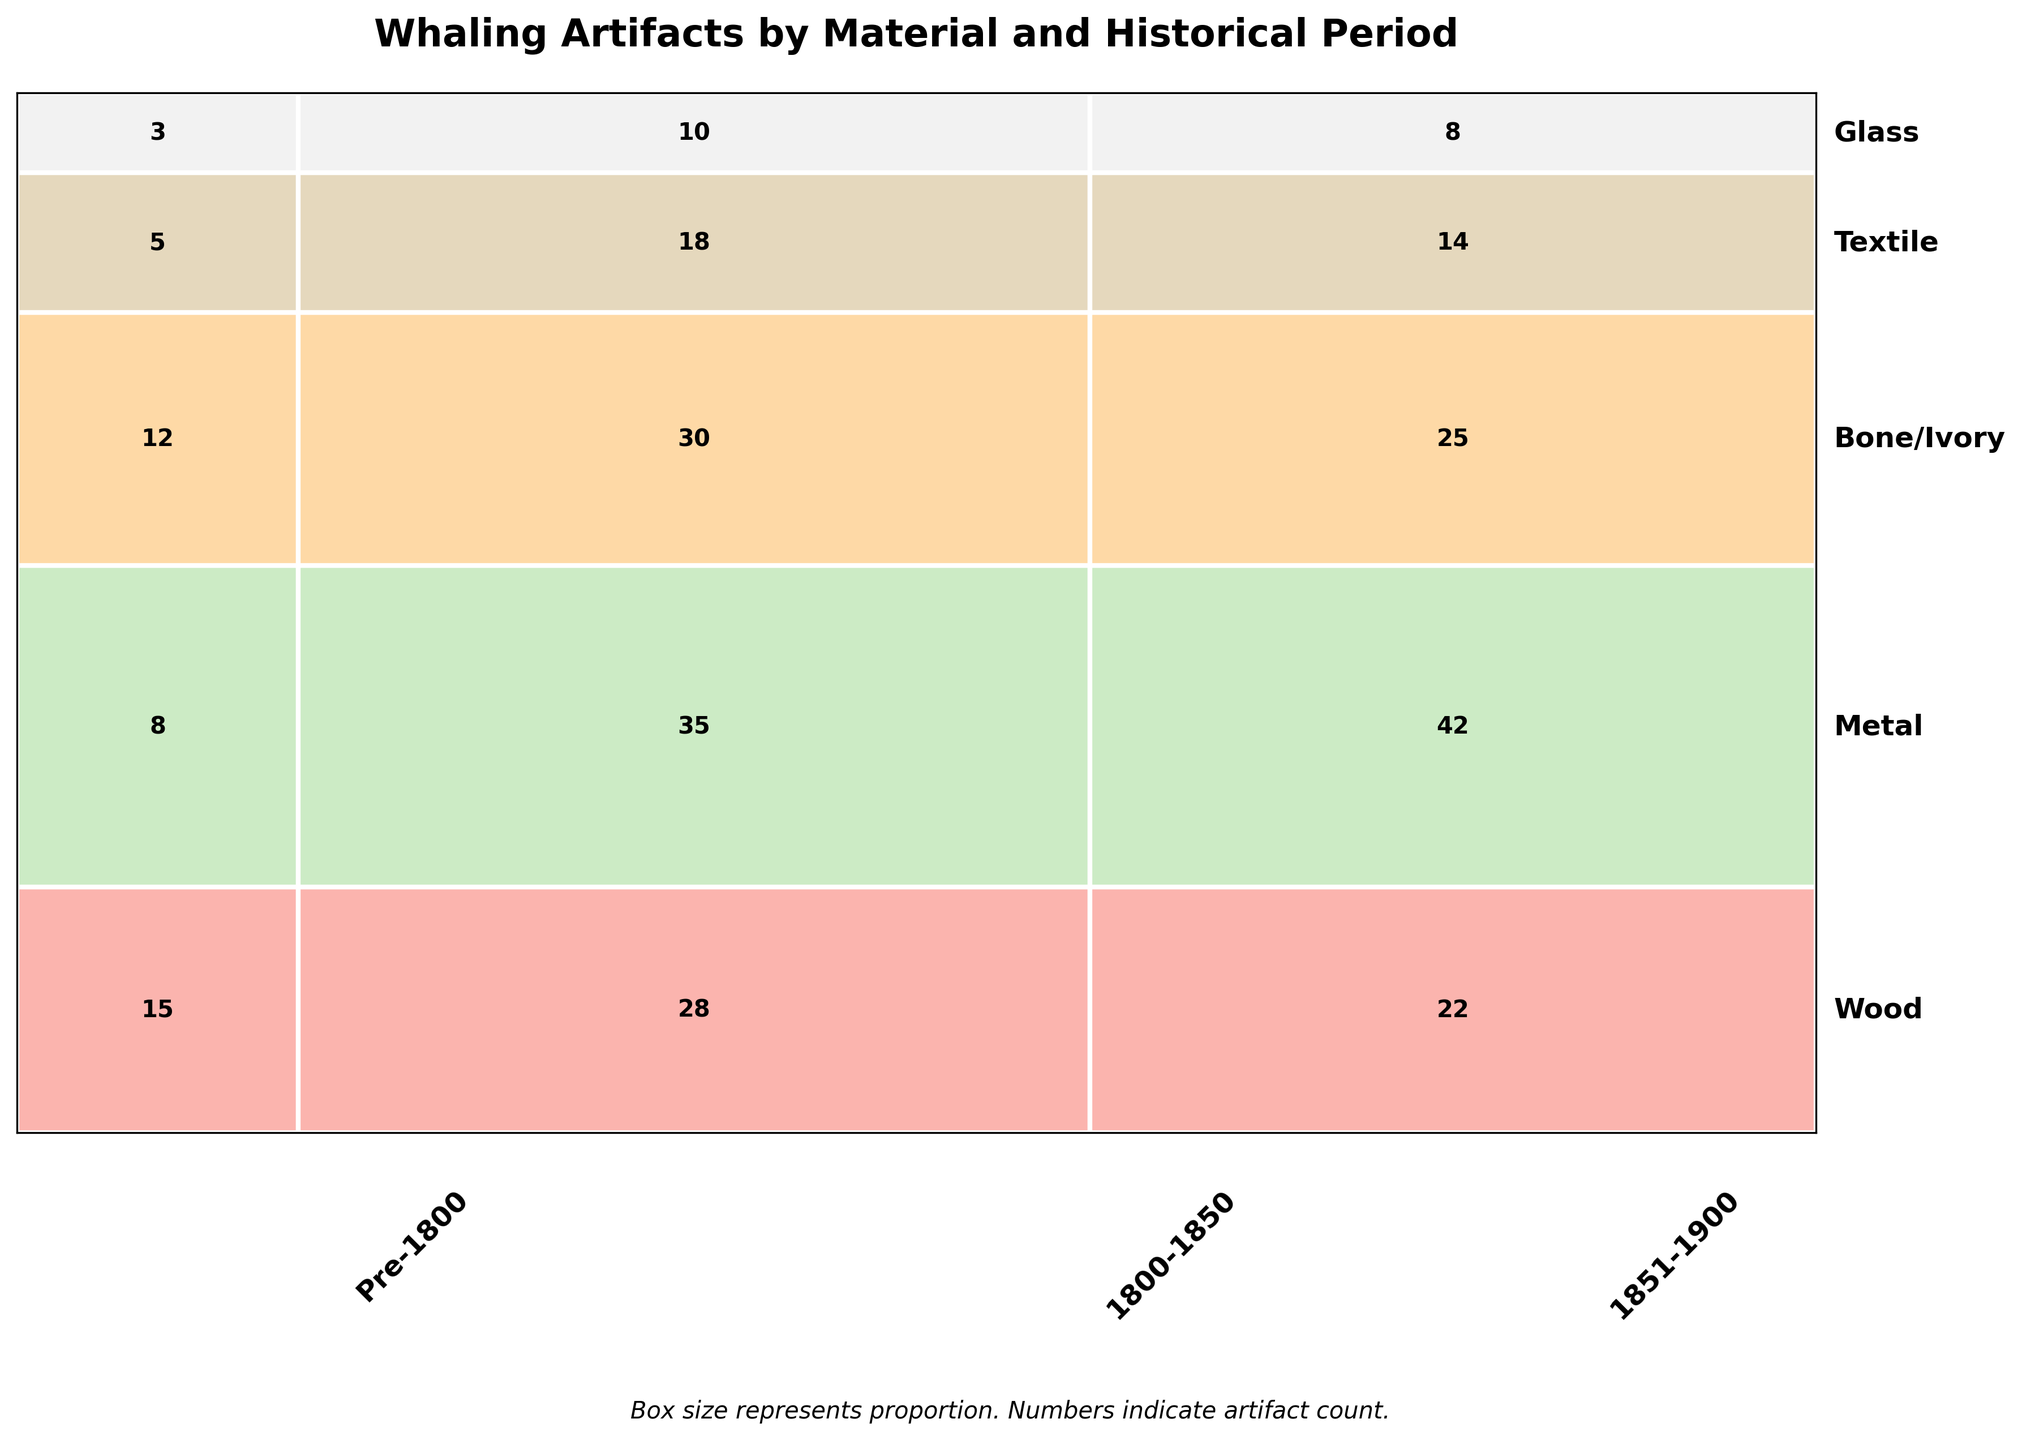Which historical period has the highest count of Wood artifacts? The area of each box is proportional to the count of artifacts. Within the Wood category, the 1800-1850 period box is the largest. Thus, the 1800-1850 period has the highest count of Wood artifacts.
Answer: 1800-1850 What is the total count of Bone/Ivory artifacts? Sum the count of Bone/Ivory artifacts across all periods: 12 (Pre-1800) + 30 (1800-1850) + 25 (1851-1900).
Answer: 67 Which material has the fewest artifacts in the Pre-1800 period? Compare the sizes of the boxes for each material in the Pre-1800 period. Glass has the smallest box.
Answer: Glass Which material category appears to have the most artifacts overall? Sum the sizes of the boxes for each material category. Metal has the largest total area across all periods.
Answer: Metal How many more Metal artifacts are there from 1851-1900 than from 1800-1850? Subtract the count of Metal artifacts from 1800-1850 from the count from 1851-1900: 42 - 35.
Answer: 7 Which historical period has the smallest total count of artifacts? Compare the total area occupied by each historical period. The Pre-1800 period appears to have the smallest total area.
Answer: Pre-1800 Are there more Textile artifacts or Glass artifacts from 1800-1850? Compare the sizes of the boxes for Textile and Glass in the 1800-1850 period. The box for Textile is larger.
Answer: Textile What’s the difference in the total number of artifacts between the 1800-1850 period and the Pre-1800 period for all materials? Sum the total counts for each period: (28+35+30+18+10) - (15+8+12+5+3).
Answer: 88 Which material sees the largest proportion increase from Pre-1800 to 1851-1900? Calculate the count proportions increase for each material. Metal increases from 8 to 42, which is the largest increase.
Answer: Metal 